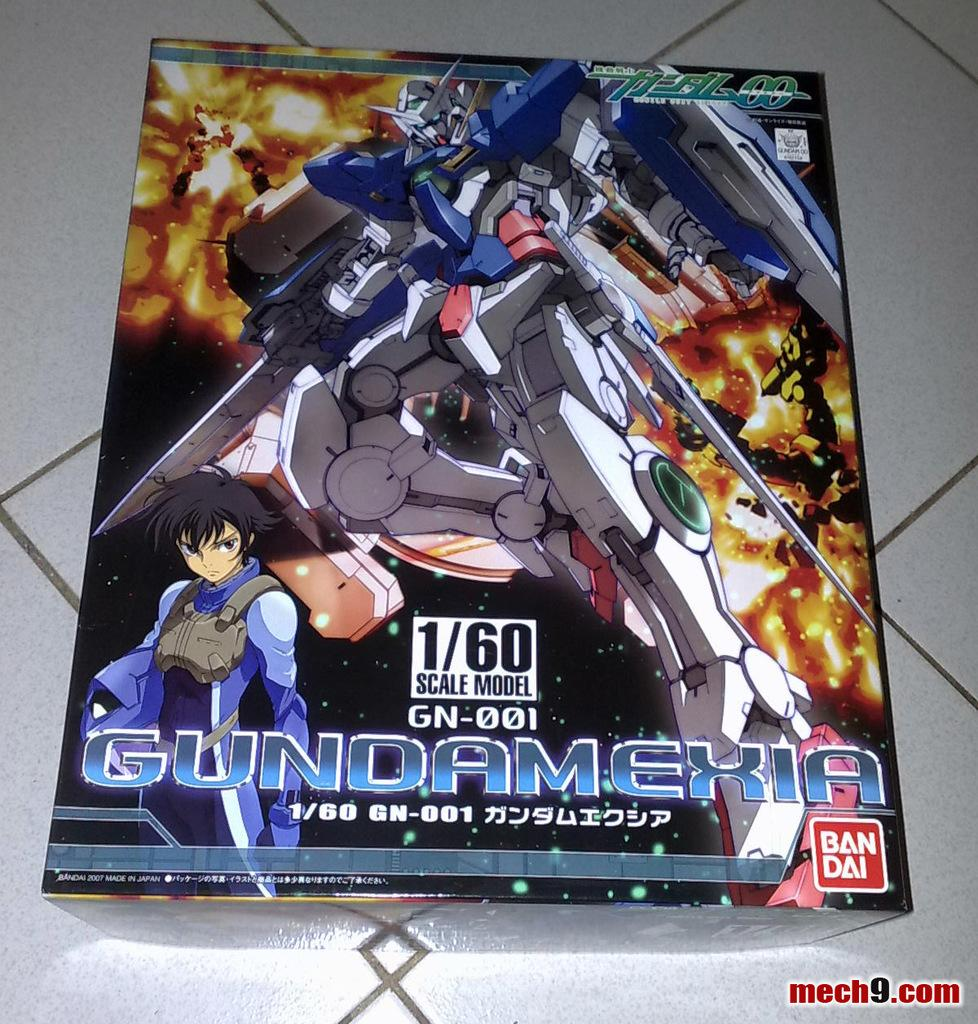<image>
Give a short and clear explanation of the subsequent image. Cover of an anime showing the word "Gundamexia" on the front. 